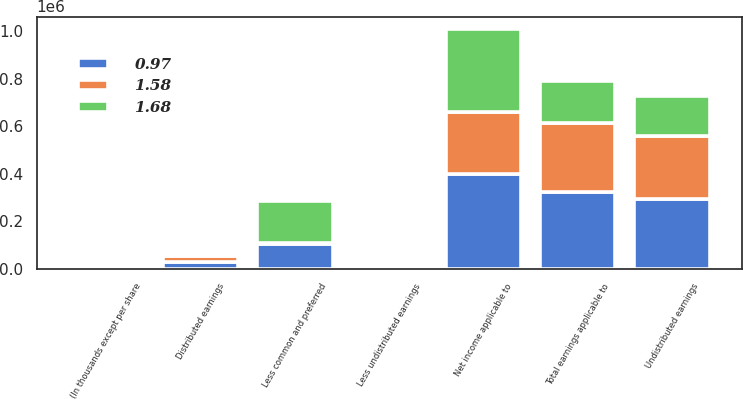Convert chart to OTSL. <chart><loc_0><loc_0><loc_500><loc_500><stacked_bar_chart><ecel><fcel>(In thousands except per share<fcel>Net income applicable to<fcel>Less common and preferred<fcel>Undistributed earnings<fcel>Less undistributed earnings<fcel>Distributed earnings<fcel>Total earnings applicable to<nl><fcel>0.97<fcel>2014<fcel>398462<fcel>103111<fcel>292418<fcel>2933<fcel>30983<fcel>323401<nl><fcel>1.58<fcel>2013<fcel>263791<fcel>6094<fcel>267053<fcel>2832<fcel>23916<fcel>290969<nl><fcel>1.68<fcel>2012<fcel>349516<fcel>178277<fcel>169639<fcel>1600<fcel>7321<fcel>176960<nl></chart> 